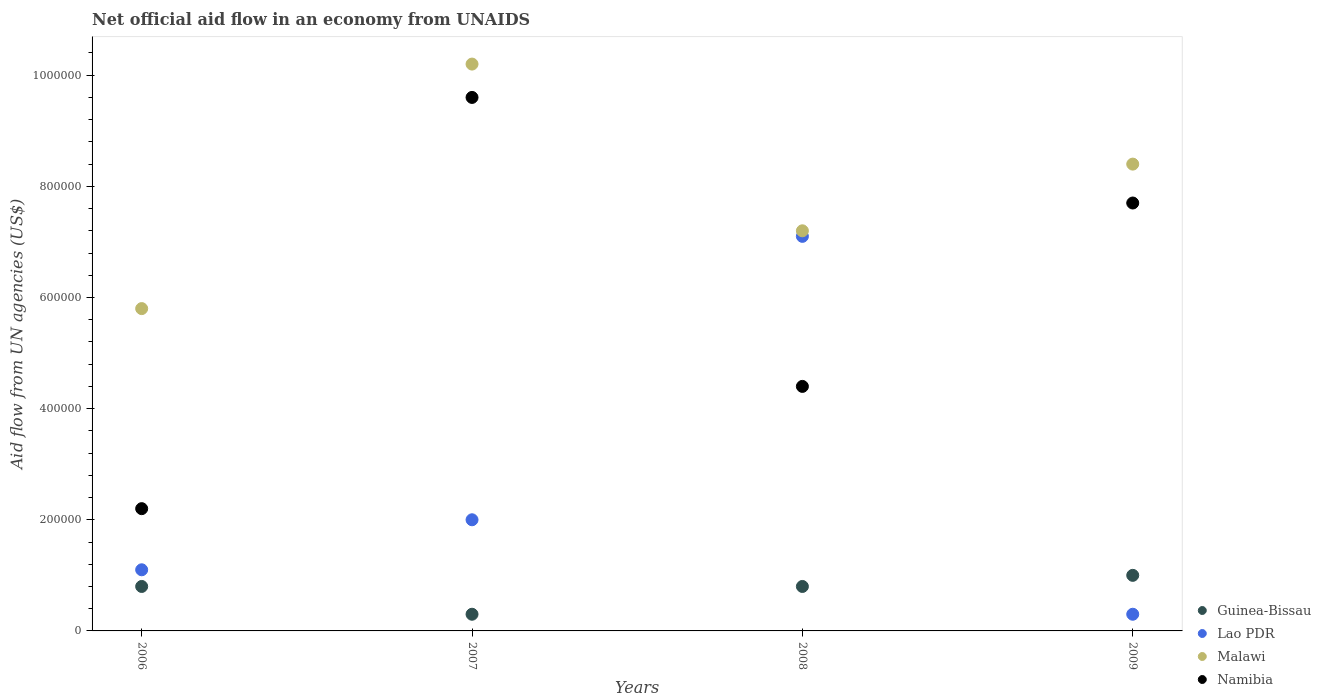What is the net official aid flow in Lao PDR in 2008?
Ensure brevity in your answer.  7.10e+05. Across all years, what is the maximum net official aid flow in Namibia?
Ensure brevity in your answer.  9.60e+05. Across all years, what is the minimum net official aid flow in Namibia?
Give a very brief answer. 2.20e+05. What is the total net official aid flow in Lao PDR in the graph?
Provide a short and direct response. 1.05e+06. What is the difference between the net official aid flow in Namibia in 2006 and that in 2007?
Offer a terse response. -7.40e+05. What is the difference between the net official aid flow in Guinea-Bissau in 2006 and the net official aid flow in Malawi in 2008?
Ensure brevity in your answer.  -6.40e+05. What is the average net official aid flow in Guinea-Bissau per year?
Give a very brief answer. 7.25e+04. In the year 2007, what is the difference between the net official aid flow in Namibia and net official aid flow in Malawi?
Your answer should be very brief. -6.00e+04. In how many years, is the net official aid flow in Namibia greater than 280000 US$?
Ensure brevity in your answer.  3. What is the ratio of the net official aid flow in Guinea-Bissau in 2007 to that in 2008?
Offer a terse response. 0.38. What is the difference between the highest and the second highest net official aid flow in Malawi?
Your answer should be very brief. 1.80e+05. What is the difference between the highest and the lowest net official aid flow in Namibia?
Make the answer very short. 7.40e+05. Is the sum of the net official aid flow in Guinea-Bissau in 2006 and 2008 greater than the maximum net official aid flow in Lao PDR across all years?
Ensure brevity in your answer.  No. Does the net official aid flow in Namibia monotonically increase over the years?
Keep it short and to the point. No. Is the net official aid flow in Guinea-Bissau strictly greater than the net official aid flow in Namibia over the years?
Offer a very short reply. No. Is the net official aid flow in Guinea-Bissau strictly less than the net official aid flow in Namibia over the years?
Your answer should be very brief. Yes. How many years are there in the graph?
Keep it short and to the point. 4. What is the difference between two consecutive major ticks on the Y-axis?
Provide a short and direct response. 2.00e+05. Are the values on the major ticks of Y-axis written in scientific E-notation?
Ensure brevity in your answer.  No. Where does the legend appear in the graph?
Ensure brevity in your answer.  Bottom right. What is the title of the graph?
Give a very brief answer. Net official aid flow in an economy from UNAIDS. What is the label or title of the Y-axis?
Your response must be concise. Aid flow from UN agencies (US$). What is the Aid flow from UN agencies (US$) in Guinea-Bissau in 2006?
Your answer should be very brief. 8.00e+04. What is the Aid flow from UN agencies (US$) in Malawi in 2006?
Keep it short and to the point. 5.80e+05. What is the Aid flow from UN agencies (US$) of Guinea-Bissau in 2007?
Offer a very short reply. 3.00e+04. What is the Aid flow from UN agencies (US$) of Malawi in 2007?
Ensure brevity in your answer.  1.02e+06. What is the Aid flow from UN agencies (US$) in Namibia in 2007?
Make the answer very short. 9.60e+05. What is the Aid flow from UN agencies (US$) of Lao PDR in 2008?
Your answer should be compact. 7.10e+05. What is the Aid flow from UN agencies (US$) of Malawi in 2008?
Provide a short and direct response. 7.20e+05. What is the Aid flow from UN agencies (US$) of Namibia in 2008?
Your answer should be compact. 4.40e+05. What is the Aid flow from UN agencies (US$) in Guinea-Bissau in 2009?
Ensure brevity in your answer.  1.00e+05. What is the Aid flow from UN agencies (US$) of Malawi in 2009?
Provide a short and direct response. 8.40e+05. What is the Aid flow from UN agencies (US$) of Namibia in 2009?
Make the answer very short. 7.70e+05. Across all years, what is the maximum Aid flow from UN agencies (US$) of Guinea-Bissau?
Keep it short and to the point. 1.00e+05. Across all years, what is the maximum Aid flow from UN agencies (US$) of Lao PDR?
Ensure brevity in your answer.  7.10e+05. Across all years, what is the maximum Aid flow from UN agencies (US$) of Malawi?
Your answer should be very brief. 1.02e+06. Across all years, what is the maximum Aid flow from UN agencies (US$) of Namibia?
Provide a short and direct response. 9.60e+05. Across all years, what is the minimum Aid flow from UN agencies (US$) of Guinea-Bissau?
Make the answer very short. 3.00e+04. Across all years, what is the minimum Aid flow from UN agencies (US$) in Malawi?
Ensure brevity in your answer.  5.80e+05. What is the total Aid flow from UN agencies (US$) in Guinea-Bissau in the graph?
Ensure brevity in your answer.  2.90e+05. What is the total Aid flow from UN agencies (US$) of Lao PDR in the graph?
Your answer should be very brief. 1.05e+06. What is the total Aid flow from UN agencies (US$) of Malawi in the graph?
Provide a succinct answer. 3.16e+06. What is the total Aid flow from UN agencies (US$) in Namibia in the graph?
Your answer should be compact. 2.39e+06. What is the difference between the Aid flow from UN agencies (US$) of Guinea-Bissau in 2006 and that in 2007?
Give a very brief answer. 5.00e+04. What is the difference between the Aid flow from UN agencies (US$) of Lao PDR in 2006 and that in 2007?
Your response must be concise. -9.00e+04. What is the difference between the Aid flow from UN agencies (US$) of Malawi in 2006 and that in 2007?
Give a very brief answer. -4.40e+05. What is the difference between the Aid flow from UN agencies (US$) in Namibia in 2006 and that in 2007?
Make the answer very short. -7.40e+05. What is the difference between the Aid flow from UN agencies (US$) of Guinea-Bissau in 2006 and that in 2008?
Your answer should be very brief. 0. What is the difference between the Aid flow from UN agencies (US$) in Lao PDR in 2006 and that in 2008?
Offer a terse response. -6.00e+05. What is the difference between the Aid flow from UN agencies (US$) in Malawi in 2006 and that in 2008?
Offer a terse response. -1.40e+05. What is the difference between the Aid flow from UN agencies (US$) in Guinea-Bissau in 2006 and that in 2009?
Offer a terse response. -2.00e+04. What is the difference between the Aid flow from UN agencies (US$) in Namibia in 2006 and that in 2009?
Make the answer very short. -5.50e+05. What is the difference between the Aid flow from UN agencies (US$) in Guinea-Bissau in 2007 and that in 2008?
Your answer should be very brief. -5.00e+04. What is the difference between the Aid flow from UN agencies (US$) of Lao PDR in 2007 and that in 2008?
Offer a very short reply. -5.10e+05. What is the difference between the Aid flow from UN agencies (US$) of Namibia in 2007 and that in 2008?
Your response must be concise. 5.20e+05. What is the difference between the Aid flow from UN agencies (US$) in Lao PDR in 2007 and that in 2009?
Offer a terse response. 1.70e+05. What is the difference between the Aid flow from UN agencies (US$) in Malawi in 2007 and that in 2009?
Provide a succinct answer. 1.80e+05. What is the difference between the Aid flow from UN agencies (US$) of Guinea-Bissau in 2008 and that in 2009?
Give a very brief answer. -2.00e+04. What is the difference between the Aid flow from UN agencies (US$) of Lao PDR in 2008 and that in 2009?
Provide a succinct answer. 6.80e+05. What is the difference between the Aid flow from UN agencies (US$) in Malawi in 2008 and that in 2009?
Offer a very short reply. -1.20e+05. What is the difference between the Aid flow from UN agencies (US$) of Namibia in 2008 and that in 2009?
Your response must be concise. -3.30e+05. What is the difference between the Aid flow from UN agencies (US$) in Guinea-Bissau in 2006 and the Aid flow from UN agencies (US$) in Lao PDR in 2007?
Your answer should be very brief. -1.20e+05. What is the difference between the Aid flow from UN agencies (US$) in Guinea-Bissau in 2006 and the Aid flow from UN agencies (US$) in Malawi in 2007?
Ensure brevity in your answer.  -9.40e+05. What is the difference between the Aid flow from UN agencies (US$) in Guinea-Bissau in 2006 and the Aid flow from UN agencies (US$) in Namibia in 2007?
Your answer should be very brief. -8.80e+05. What is the difference between the Aid flow from UN agencies (US$) of Lao PDR in 2006 and the Aid flow from UN agencies (US$) of Malawi in 2007?
Your answer should be compact. -9.10e+05. What is the difference between the Aid flow from UN agencies (US$) in Lao PDR in 2006 and the Aid flow from UN agencies (US$) in Namibia in 2007?
Your response must be concise. -8.50e+05. What is the difference between the Aid flow from UN agencies (US$) of Malawi in 2006 and the Aid flow from UN agencies (US$) of Namibia in 2007?
Your answer should be very brief. -3.80e+05. What is the difference between the Aid flow from UN agencies (US$) in Guinea-Bissau in 2006 and the Aid flow from UN agencies (US$) in Lao PDR in 2008?
Your answer should be compact. -6.30e+05. What is the difference between the Aid flow from UN agencies (US$) of Guinea-Bissau in 2006 and the Aid flow from UN agencies (US$) of Malawi in 2008?
Offer a very short reply. -6.40e+05. What is the difference between the Aid flow from UN agencies (US$) of Guinea-Bissau in 2006 and the Aid flow from UN agencies (US$) of Namibia in 2008?
Ensure brevity in your answer.  -3.60e+05. What is the difference between the Aid flow from UN agencies (US$) of Lao PDR in 2006 and the Aid flow from UN agencies (US$) of Malawi in 2008?
Give a very brief answer. -6.10e+05. What is the difference between the Aid flow from UN agencies (US$) in Lao PDR in 2006 and the Aid flow from UN agencies (US$) in Namibia in 2008?
Ensure brevity in your answer.  -3.30e+05. What is the difference between the Aid flow from UN agencies (US$) of Malawi in 2006 and the Aid flow from UN agencies (US$) of Namibia in 2008?
Offer a terse response. 1.40e+05. What is the difference between the Aid flow from UN agencies (US$) of Guinea-Bissau in 2006 and the Aid flow from UN agencies (US$) of Malawi in 2009?
Offer a terse response. -7.60e+05. What is the difference between the Aid flow from UN agencies (US$) of Guinea-Bissau in 2006 and the Aid flow from UN agencies (US$) of Namibia in 2009?
Your answer should be very brief. -6.90e+05. What is the difference between the Aid flow from UN agencies (US$) in Lao PDR in 2006 and the Aid flow from UN agencies (US$) in Malawi in 2009?
Provide a succinct answer. -7.30e+05. What is the difference between the Aid flow from UN agencies (US$) in Lao PDR in 2006 and the Aid flow from UN agencies (US$) in Namibia in 2009?
Your answer should be compact. -6.60e+05. What is the difference between the Aid flow from UN agencies (US$) of Malawi in 2006 and the Aid flow from UN agencies (US$) of Namibia in 2009?
Your response must be concise. -1.90e+05. What is the difference between the Aid flow from UN agencies (US$) in Guinea-Bissau in 2007 and the Aid flow from UN agencies (US$) in Lao PDR in 2008?
Make the answer very short. -6.80e+05. What is the difference between the Aid flow from UN agencies (US$) in Guinea-Bissau in 2007 and the Aid flow from UN agencies (US$) in Malawi in 2008?
Your answer should be compact. -6.90e+05. What is the difference between the Aid flow from UN agencies (US$) in Guinea-Bissau in 2007 and the Aid flow from UN agencies (US$) in Namibia in 2008?
Ensure brevity in your answer.  -4.10e+05. What is the difference between the Aid flow from UN agencies (US$) in Lao PDR in 2007 and the Aid flow from UN agencies (US$) in Malawi in 2008?
Give a very brief answer. -5.20e+05. What is the difference between the Aid flow from UN agencies (US$) of Lao PDR in 2007 and the Aid flow from UN agencies (US$) of Namibia in 2008?
Provide a succinct answer. -2.40e+05. What is the difference between the Aid flow from UN agencies (US$) of Malawi in 2007 and the Aid flow from UN agencies (US$) of Namibia in 2008?
Make the answer very short. 5.80e+05. What is the difference between the Aid flow from UN agencies (US$) of Guinea-Bissau in 2007 and the Aid flow from UN agencies (US$) of Lao PDR in 2009?
Give a very brief answer. 0. What is the difference between the Aid flow from UN agencies (US$) in Guinea-Bissau in 2007 and the Aid flow from UN agencies (US$) in Malawi in 2009?
Give a very brief answer. -8.10e+05. What is the difference between the Aid flow from UN agencies (US$) of Guinea-Bissau in 2007 and the Aid flow from UN agencies (US$) of Namibia in 2009?
Offer a terse response. -7.40e+05. What is the difference between the Aid flow from UN agencies (US$) of Lao PDR in 2007 and the Aid flow from UN agencies (US$) of Malawi in 2009?
Provide a succinct answer. -6.40e+05. What is the difference between the Aid flow from UN agencies (US$) of Lao PDR in 2007 and the Aid flow from UN agencies (US$) of Namibia in 2009?
Offer a terse response. -5.70e+05. What is the difference between the Aid flow from UN agencies (US$) in Malawi in 2007 and the Aid flow from UN agencies (US$) in Namibia in 2009?
Offer a very short reply. 2.50e+05. What is the difference between the Aid flow from UN agencies (US$) in Guinea-Bissau in 2008 and the Aid flow from UN agencies (US$) in Malawi in 2009?
Give a very brief answer. -7.60e+05. What is the difference between the Aid flow from UN agencies (US$) of Guinea-Bissau in 2008 and the Aid flow from UN agencies (US$) of Namibia in 2009?
Offer a very short reply. -6.90e+05. What is the difference between the Aid flow from UN agencies (US$) in Malawi in 2008 and the Aid flow from UN agencies (US$) in Namibia in 2009?
Make the answer very short. -5.00e+04. What is the average Aid flow from UN agencies (US$) in Guinea-Bissau per year?
Ensure brevity in your answer.  7.25e+04. What is the average Aid flow from UN agencies (US$) in Lao PDR per year?
Offer a terse response. 2.62e+05. What is the average Aid flow from UN agencies (US$) of Malawi per year?
Your answer should be very brief. 7.90e+05. What is the average Aid flow from UN agencies (US$) in Namibia per year?
Your answer should be compact. 5.98e+05. In the year 2006, what is the difference between the Aid flow from UN agencies (US$) in Guinea-Bissau and Aid flow from UN agencies (US$) in Lao PDR?
Offer a very short reply. -3.00e+04. In the year 2006, what is the difference between the Aid flow from UN agencies (US$) in Guinea-Bissau and Aid flow from UN agencies (US$) in Malawi?
Make the answer very short. -5.00e+05. In the year 2006, what is the difference between the Aid flow from UN agencies (US$) of Guinea-Bissau and Aid flow from UN agencies (US$) of Namibia?
Give a very brief answer. -1.40e+05. In the year 2006, what is the difference between the Aid flow from UN agencies (US$) of Lao PDR and Aid flow from UN agencies (US$) of Malawi?
Keep it short and to the point. -4.70e+05. In the year 2006, what is the difference between the Aid flow from UN agencies (US$) in Lao PDR and Aid flow from UN agencies (US$) in Namibia?
Provide a short and direct response. -1.10e+05. In the year 2006, what is the difference between the Aid flow from UN agencies (US$) of Malawi and Aid flow from UN agencies (US$) of Namibia?
Ensure brevity in your answer.  3.60e+05. In the year 2007, what is the difference between the Aid flow from UN agencies (US$) in Guinea-Bissau and Aid flow from UN agencies (US$) in Malawi?
Your answer should be very brief. -9.90e+05. In the year 2007, what is the difference between the Aid flow from UN agencies (US$) in Guinea-Bissau and Aid flow from UN agencies (US$) in Namibia?
Make the answer very short. -9.30e+05. In the year 2007, what is the difference between the Aid flow from UN agencies (US$) of Lao PDR and Aid flow from UN agencies (US$) of Malawi?
Provide a short and direct response. -8.20e+05. In the year 2007, what is the difference between the Aid flow from UN agencies (US$) in Lao PDR and Aid flow from UN agencies (US$) in Namibia?
Ensure brevity in your answer.  -7.60e+05. In the year 2007, what is the difference between the Aid flow from UN agencies (US$) of Malawi and Aid flow from UN agencies (US$) of Namibia?
Make the answer very short. 6.00e+04. In the year 2008, what is the difference between the Aid flow from UN agencies (US$) in Guinea-Bissau and Aid flow from UN agencies (US$) in Lao PDR?
Your response must be concise. -6.30e+05. In the year 2008, what is the difference between the Aid flow from UN agencies (US$) of Guinea-Bissau and Aid flow from UN agencies (US$) of Malawi?
Your answer should be compact. -6.40e+05. In the year 2008, what is the difference between the Aid flow from UN agencies (US$) in Guinea-Bissau and Aid flow from UN agencies (US$) in Namibia?
Ensure brevity in your answer.  -3.60e+05. In the year 2008, what is the difference between the Aid flow from UN agencies (US$) of Lao PDR and Aid flow from UN agencies (US$) of Malawi?
Keep it short and to the point. -10000. In the year 2009, what is the difference between the Aid flow from UN agencies (US$) of Guinea-Bissau and Aid flow from UN agencies (US$) of Lao PDR?
Ensure brevity in your answer.  7.00e+04. In the year 2009, what is the difference between the Aid flow from UN agencies (US$) in Guinea-Bissau and Aid flow from UN agencies (US$) in Malawi?
Offer a terse response. -7.40e+05. In the year 2009, what is the difference between the Aid flow from UN agencies (US$) of Guinea-Bissau and Aid flow from UN agencies (US$) of Namibia?
Provide a short and direct response. -6.70e+05. In the year 2009, what is the difference between the Aid flow from UN agencies (US$) of Lao PDR and Aid flow from UN agencies (US$) of Malawi?
Ensure brevity in your answer.  -8.10e+05. In the year 2009, what is the difference between the Aid flow from UN agencies (US$) in Lao PDR and Aid flow from UN agencies (US$) in Namibia?
Give a very brief answer. -7.40e+05. What is the ratio of the Aid flow from UN agencies (US$) in Guinea-Bissau in 2006 to that in 2007?
Offer a terse response. 2.67. What is the ratio of the Aid flow from UN agencies (US$) of Lao PDR in 2006 to that in 2007?
Your answer should be compact. 0.55. What is the ratio of the Aid flow from UN agencies (US$) of Malawi in 2006 to that in 2007?
Offer a very short reply. 0.57. What is the ratio of the Aid flow from UN agencies (US$) of Namibia in 2006 to that in 2007?
Your answer should be very brief. 0.23. What is the ratio of the Aid flow from UN agencies (US$) in Lao PDR in 2006 to that in 2008?
Keep it short and to the point. 0.15. What is the ratio of the Aid flow from UN agencies (US$) in Malawi in 2006 to that in 2008?
Your answer should be very brief. 0.81. What is the ratio of the Aid flow from UN agencies (US$) of Namibia in 2006 to that in 2008?
Your answer should be compact. 0.5. What is the ratio of the Aid flow from UN agencies (US$) in Guinea-Bissau in 2006 to that in 2009?
Your answer should be very brief. 0.8. What is the ratio of the Aid flow from UN agencies (US$) of Lao PDR in 2006 to that in 2009?
Make the answer very short. 3.67. What is the ratio of the Aid flow from UN agencies (US$) of Malawi in 2006 to that in 2009?
Offer a terse response. 0.69. What is the ratio of the Aid flow from UN agencies (US$) of Namibia in 2006 to that in 2009?
Offer a very short reply. 0.29. What is the ratio of the Aid flow from UN agencies (US$) in Lao PDR in 2007 to that in 2008?
Provide a short and direct response. 0.28. What is the ratio of the Aid flow from UN agencies (US$) of Malawi in 2007 to that in 2008?
Your answer should be compact. 1.42. What is the ratio of the Aid flow from UN agencies (US$) of Namibia in 2007 to that in 2008?
Make the answer very short. 2.18. What is the ratio of the Aid flow from UN agencies (US$) in Malawi in 2007 to that in 2009?
Make the answer very short. 1.21. What is the ratio of the Aid flow from UN agencies (US$) in Namibia in 2007 to that in 2009?
Provide a short and direct response. 1.25. What is the ratio of the Aid flow from UN agencies (US$) in Lao PDR in 2008 to that in 2009?
Give a very brief answer. 23.67. What is the ratio of the Aid flow from UN agencies (US$) in Namibia in 2008 to that in 2009?
Your answer should be very brief. 0.57. What is the difference between the highest and the second highest Aid flow from UN agencies (US$) in Lao PDR?
Keep it short and to the point. 5.10e+05. What is the difference between the highest and the second highest Aid flow from UN agencies (US$) in Malawi?
Keep it short and to the point. 1.80e+05. What is the difference between the highest and the second highest Aid flow from UN agencies (US$) in Namibia?
Offer a terse response. 1.90e+05. What is the difference between the highest and the lowest Aid flow from UN agencies (US$) in Lao PDR?
Ensure brevity in your answer.  6.80e+05. What is the difference between the highest and the lowest Aid flow from UN agencies (US$) of Malawi?
Make the answer very short. 4.40e+05. What is the difference between the highest and the lowest Aid flow from UN agencies (US$) in Namibia?
Make the answer very short. 7.40e+05. 